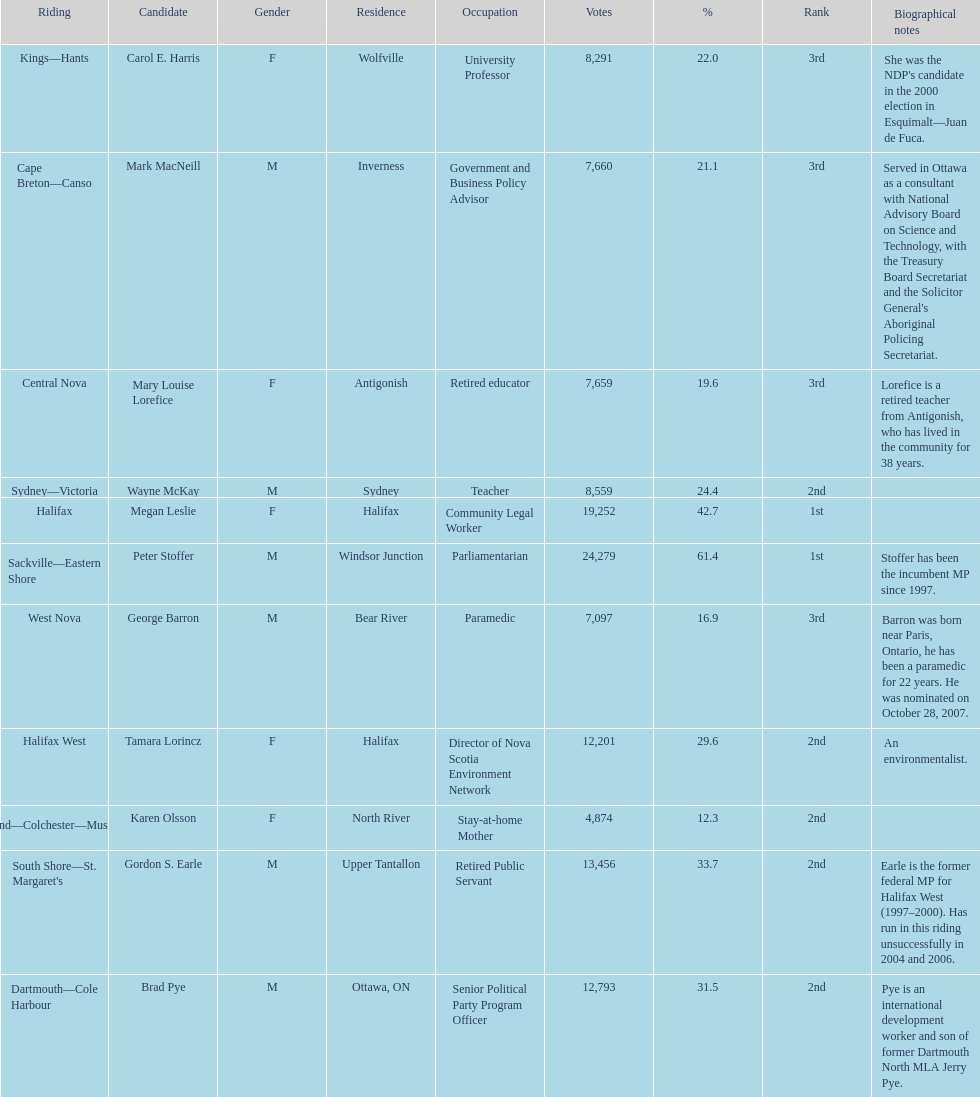How many candidates were from halifax? 2. 